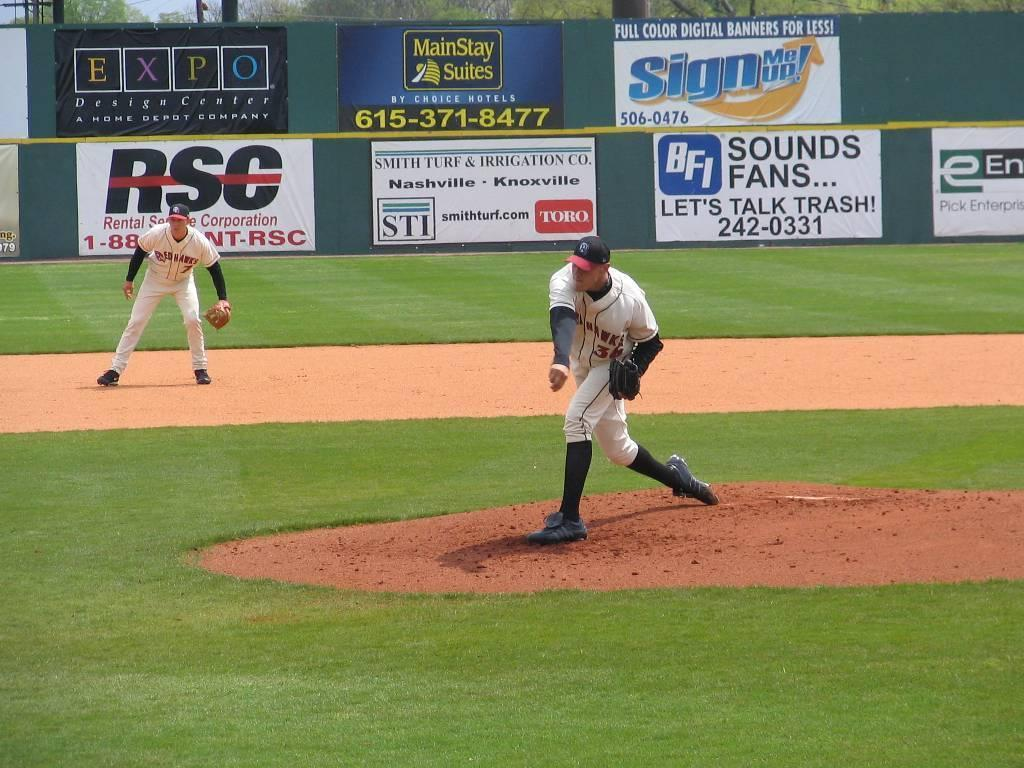<image>
Present a compact description of the photo's key features. a player pitching with an RSC logo in the back 